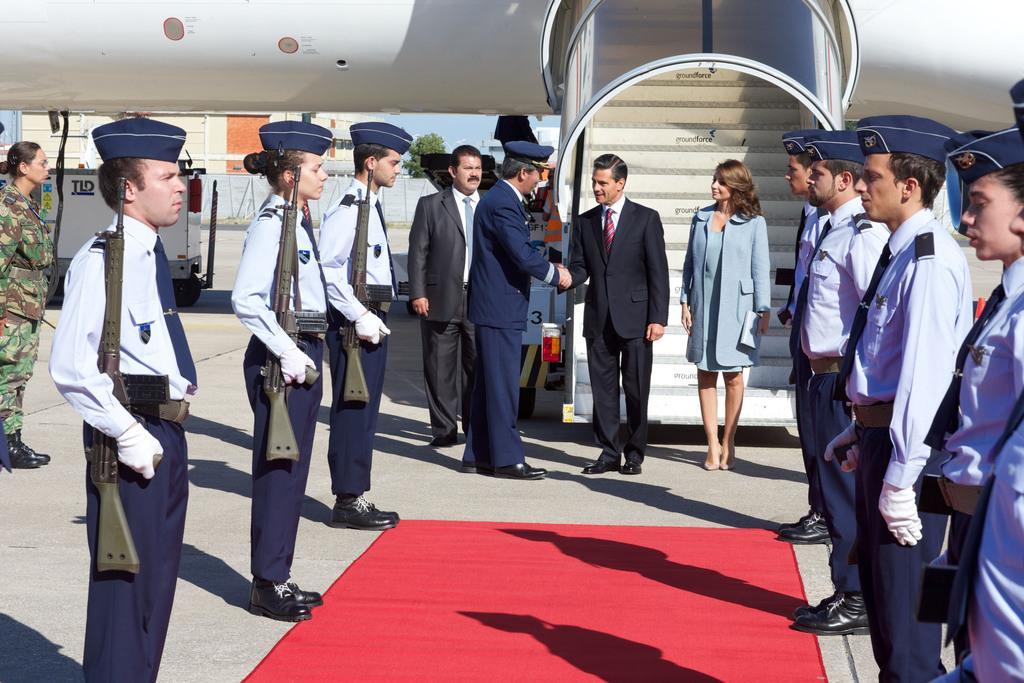Can you describe this image briefly? In this image I can see in the middle a man is standing and speaking, he wore a black color coat, trouser. Beside him a beautiful woman is also standing, behind them there is the staircase of an aeroplane, few people are standing on either side of this image, holding the weapons, wearing the caps in blue color. At the bottom it is the red carpet. 